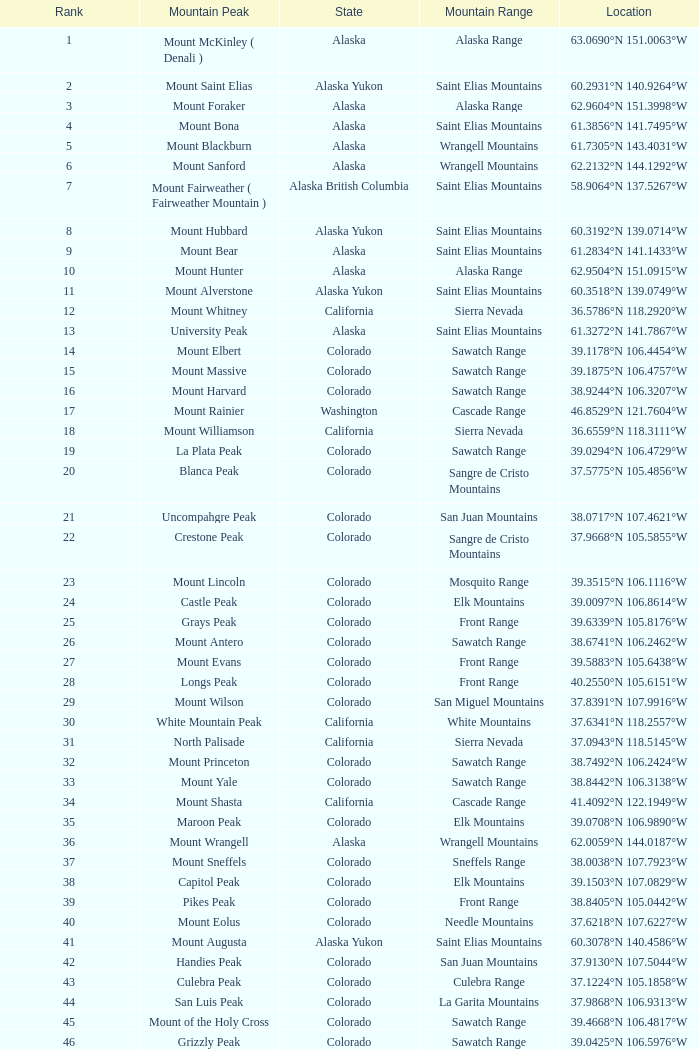What is the position when the state is colorado and the coordinates are 37.7859°n 107.7039°w? 83.0. 